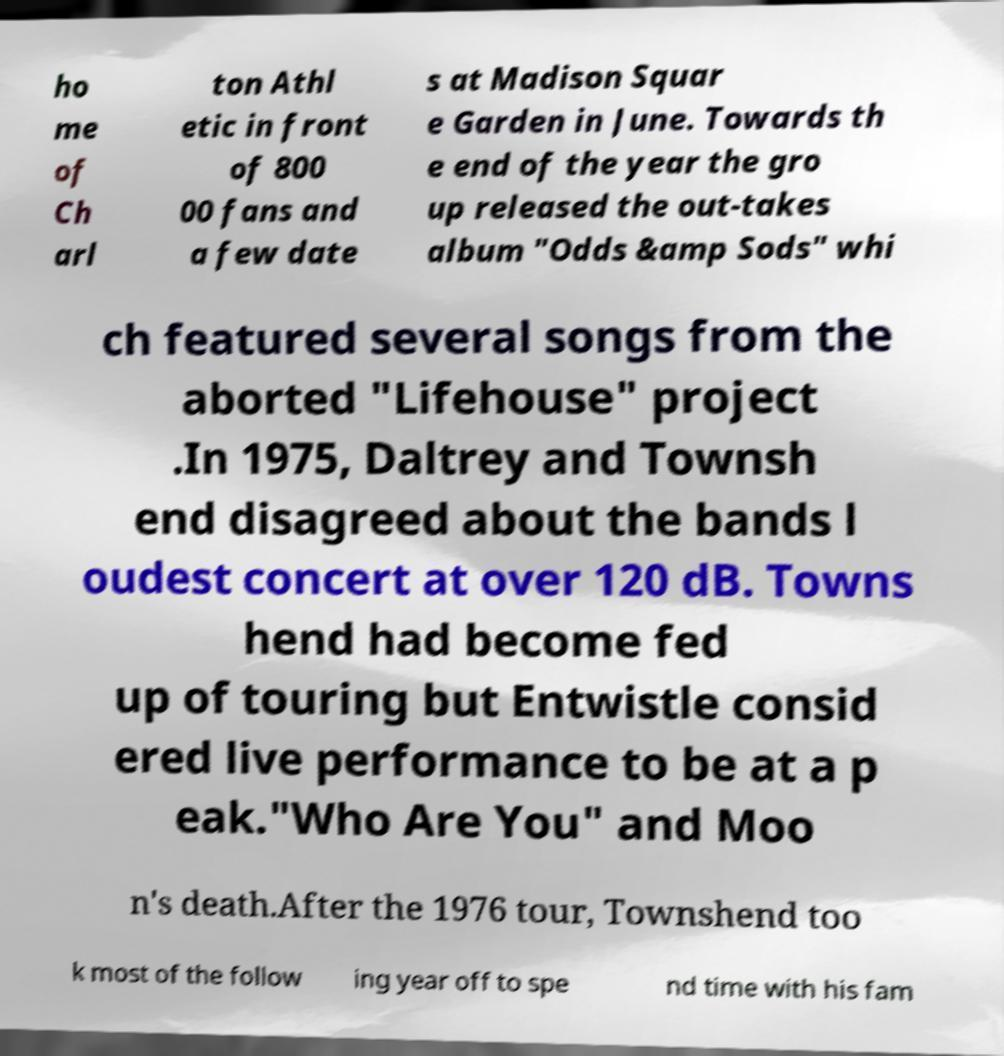Can you read and provide the text displayed in the image?This photo seems to have some interesting text. Can you extract and type it out for me? ho me of Ch arl ton Athl etic in front of 800 00 fans and a few date s at Madison Squar e Garden in June. Towards th e end of the year the gro up released the out-takes album "Odds &amp Sods" whi ch featured several songs from the aborted "Lifehouse" project .In 1975, Daltrey and Townsh end disagreed about the bands l oudest concert at over 120 dB. Towns hend had become fed up of touring but Entwistle consid ered live performance to be at a p eak."Who Are You" and Moo n's death.After the 1976 tour, Townshend too k most of the follow ing year off to spe nd time with his fam 